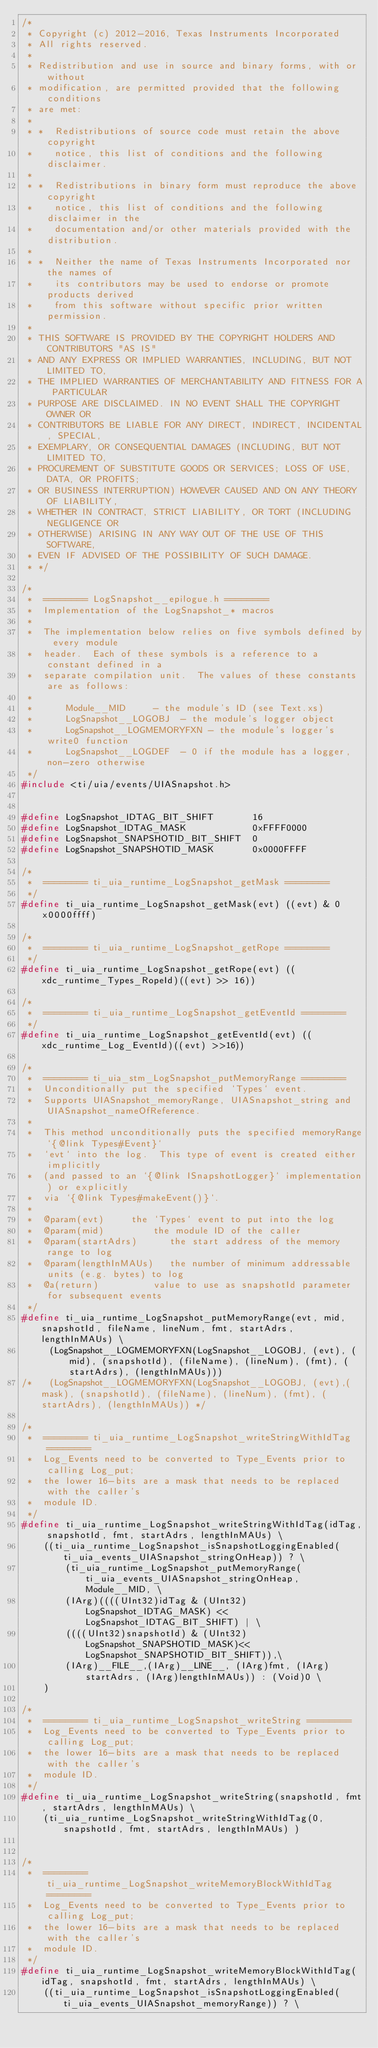Convert code to text. <code><loc_0><loc_0><loc_500><loc_500><_C_>/*
 * Copyright (c) 2012-2016, Texas Instruments Incorporated
 * All rights reserved.
 *
 * Redistribution and use in source and binary forms, with or without
 * modification, are permitted provided that the following conditions
 * are met:
 *
 * *  Redistributions of source code must retain the above copyright
 *    notice, this list of conditions and the following disclaimer.
 *
 * *  Redistributions in binary form must reproduce the above copyright
 *    notice, this list of conditions and the following disclaimer in the
 *    documentation and/or other materials provided with the distribution.
 *
 * *  Neither the name of Texas Instruments Incorporated nor the names of
 *    its contributors may be used to endorse or promote products derived
 *    from this software without specific prior written permission.
 *
 * THIS SOFTWARE IS PROVIDED BY THE COPYRIGHT HOLDERS AND CONTRIBUTORS "AS IS"
 * AND ANY EXPRESS OR IMPLIED WARRANTIES, INCLUDING, BUT NOT LIMITED TO,
 * THE IMPLIED WARRANTIES OF MERCHANTABILITY AND FITNESS FOR A PARTICULAR
 * PURPOSE ARE DISCLAIMED. IN NO EVENT SHALL THE COPYRIGHT OWNER OR
 * CONTRIBUTORS BE LIABLE FOR ANY DIRECT, INDIRECT, INCIDENTAL, SPECIAL,
 * EXEMPLARY, OR CONSEQUENTIAL DAMAGES (INCLUDING, BUT NOT LIMITED TO,
 * PROCUREMENT OF SUBSTITUTE GOODS OR SERVICES; LOSS OF USE, DATA, OR PROFITS;
 * OR BUSINESS INTERRUPTION) HOWEVER CAUSED AND ON ANY THEORY OF LIABILITY,
 * WHETHER IN CONTRACT, STRICT LIABILITY, OR TORT (INCLUDING NEGLIGENCE OR
 * OTHERWISE) ARISING IN ANY WAY OUT OF THE USE OF THIS SOFTWARE,
 * EVEN IF ADVISED OF THE POSSIBILITY OF SUCH DAMAGE.
 * */

/*
 *  ======== LogSnapshot__epilogue.h ========
 *  Implementation of the LogSnapshot_* macros
 *
 *  The implementation below relies on five symbols defined by every module
 *  header.  Each of these symbols is a reference to a constant defined in a
 *  separate compilation unit.  The values of these constants are as follows:
 *
 *      Module__MID     - the module's ID (see Text.xs)
 *      LogSnapshot__LOGOBJ  - the module's logger object
 *      LogSnapshot__LOGMEMORYFXN - the module's logger's write0 function
 *      LogSnapshot__LOGDEF  - 0 if the module has a logger, non-zero otherwise
 */
#include <ti/uia/events/UIASnapshot.h>


#define LogSnapshot_IDTAG_BIT_SHIFT       16
#define LogSnapshot_IDTAG_MASK            0xFFFF0000
#define LogSnapshot_SNAPSHOTID_BIT_SHIFT  0
#define LogSnapshot_SNAPSHOTID_MASK       0x0000FFFF

/*
 *  ======== ti_uia_runtime_LogSnapshot_getMask ========
 */
#define ti_uia_runtime_LogSnapshot_getMask(evt) ((evt) & 0x0000ffff)

/*
 *  ======== ti_uia_runtime_LogSnapshot_getRope ========
 */
#define ti_uia_runtime_LogSnapshot_getRope(evt) ((xdc_runtime_Types_RopeId)((evt) >> 16))

/*
 *  ======== ti_uia_runtime_LogSnapshot_getEventId ========
 */
#define ti_uia_runtime_LogSnapshot_getEventId(evt) ((xdc_runtime_Log_EventId)((evt) >>16))

/*
 *  ======== ti_uia_stm_LogSnapshot_putMemoryRange ========
 *  Unconditionally put the specified `Types` event.
 *  Supports UIASnapshot_memoryRange, UIASnapshot_string and UIASnapshot_nameOfReference.
 *
 *  This method unconditionally puts the specified memoryRange`{@link Types#Event}`
 *  `evt` into the log.  This type of event is created either implicitly
 *  (and passed to an `{@link ISnapshotLogger}` implementation) or explicitly
 *  via `{@link Types#makeEvent()}`.
 *
 *  @param(evt)     the `Types` event to put into the log
 *  @param(mid)         the module ID of the caller
 *  @param(startAdrs)      the start address of the memory range to log
 *  @param(lengthInMAUs)   the number of minimum addressable units (e.g. bytes) to log
 *  @a(return)          value to use as snapshotId parameter for subsequent events
 */
#define ti_uia_runtime_LogSnapshot_putMemoryRange(evt, mid, snapshotId, fileName, lineNum, fmt, startAdrs, lengthInMAUs) \
     (LogSnapshot__LOGMEMORYFXN(LogSnapshot__LOGOBJ, (evt), (mid), (snapshotId), (fileName), (lineNum), (fmt), (startAdrs), (lengthInMAUs)))
/*   (LogSnapshot__LOGMEMORYFXN(LogSnapshot__LOGOBJ, (evt),(mask), (snapshotId), (fileName), (lineNum), (fmt), (startAdrs), (lengthInMAUs)) */

/*
 *  ======== ti_uia_runtime_LogSnapshot_writeStringWithIdTag ========
 *  Log_Events need to be converted to Type_Events prior to calling Log_put;
 *  the lower 16-bits are a mask that needs to be replaced with the caller's
 *  module ID.
 */
#define ti_uia_runtime_LogSnapshot_writeStringWithIdTag(idTag, snapshotId, fmt, startAdrs, lengthInMAUs) \
    ((ti_uia_runtime_LogSnapshot_isSnapshotLoggingEnabled(ti_uia_events_UIASnapshot_stringOnHeap)) ? \
        (ti_uia_runtime_LogSnapshot_putMemoryRange(ti_uia_events_UIASnapshot_stringOnHeap, Module__MID, \
        (IArg)((((UInt32)idTag & (UInt32)LogSnapshot_IDTAG_MASK) << LogSnapshot_IDTAG_BIT_SHIFT) | \
        ((((UInt32)snapshotId) & (UInt32)LogSnapshot_SNAPSHOTID_MASK)<<LogSnapshot_SNAPSHOTID_BIT_SHIFT)),\
        (IArg)__FILE__,(IArg)__LINE__, (IArg)fmt, (IArg)startAdrs, (IArg)lengthInMAUs)) : (Void)0 \
    )

/*
 *  ======== ti_uia_runtime_LogSnapshot_writeString ========
 *  Log_Events need to be converted to Type_Events prior to calling Log_put;
 *  the lower 16-bits are a mask that needs to be replaced with the caller's
 *  module ID.
 */
#define ti_uia_runtime_LogSnapshot_writeString(snapshotId, fmt, startAdrs, lengthInMAUs) \
    (ti_uia_runtime_LogSnapshot_writeStringWithIdTag(0, snapshotId, fmt, startAdrs, lengthInMAUs) )


/*
 *  ======== ti_uia_runtime_LogSnapshot_writeMemoryBlockWithIdTag ========
 *  Log_Events need to be converted to Type_Events prior to calling Log_put;
 *  the lower 16-bits are a mask that needs to be replaced with the caller's
 *  module ID.
 */
#define ti_uia_runtime_LogSnapshot_writeMemoryBlockWithIdTag(idTag, snapshotId, fmt, startAdrs, lengthInMAUs) \
    ((ti_uia_runtime_LogSnapshot_isSnapshotLoggingEnabled(ti_uia_events_UIASnapshot_memoryRange)) ? \</code> 